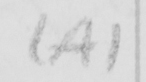Can you read and transcribe this handwriting? ( A ) 